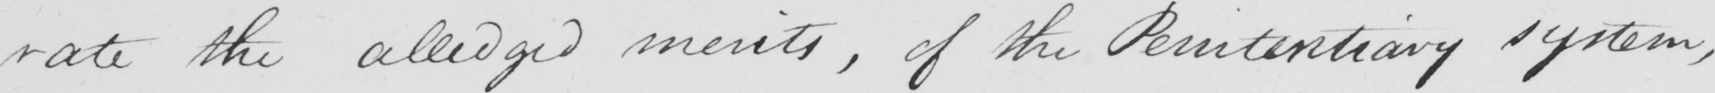What is written in this line of handwriting? rate the alledged merits , of the Penitentiary system , 